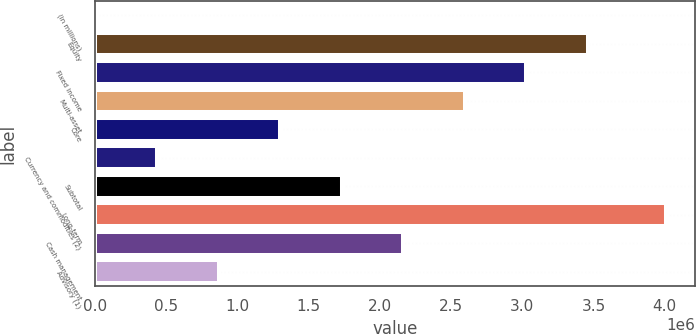<chart> <loc_0><loc_0><loc_500><loc_500><bar_chart><fcel>(in millions)<fcel>Equity<fcel>Fixed income<fcel>Multi-asset<fcel>Core<fcel>Currency and commodities (2)<fcel>Subtotal<fcel>Long-term<fcel>Cash management<fcel>Advisory (1)<nl><fcel>2013<fcel>3.45967e+06<fcel>3.02747e+06<fcel>2.59526e+06<fcel>1.29864e+06<fcel>434220<fcel>1.73084e+06<fcel>4.01221e+06<fcel>2.16305e+06<fcel>866428<nl></chart> 